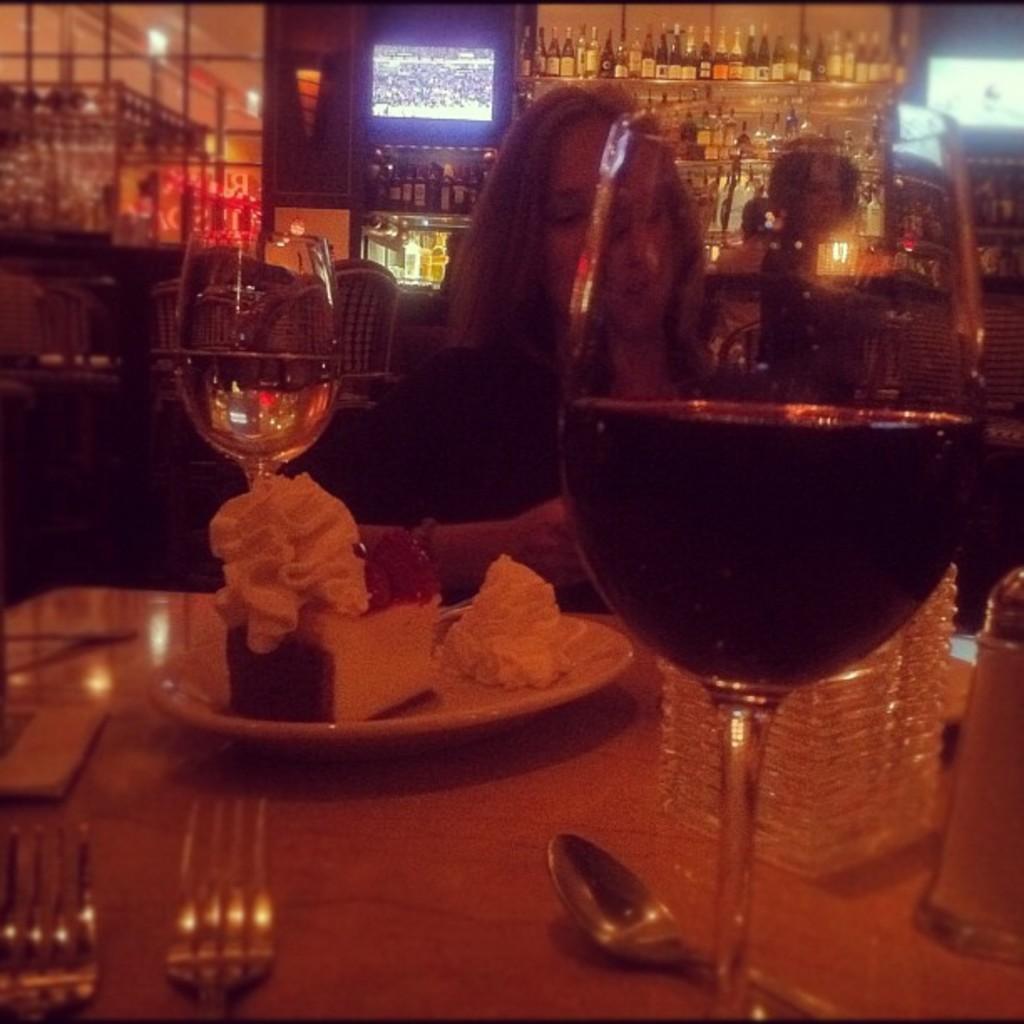Describe this image in one or two sentences. On the background we can see bottles arranged in a rack. This is a television. Here we can see one women sitting on a chair in front of a table and on the table we can see drinking glasses, spoon, forks, tissue paper. 